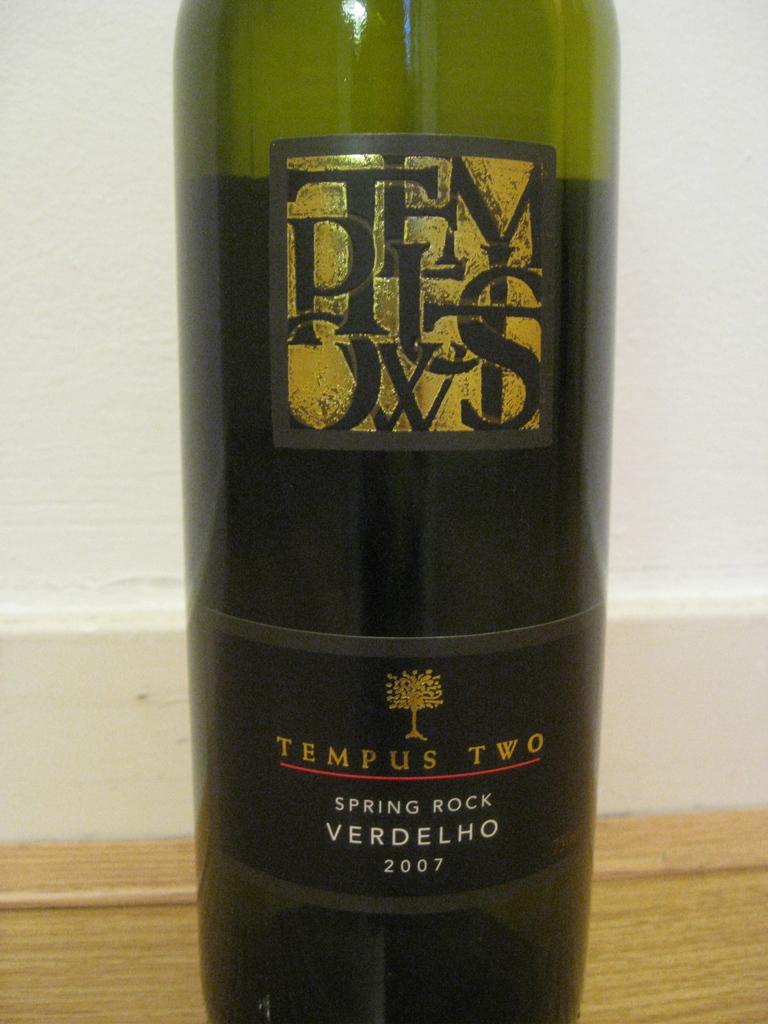Is tempus two a light or dark alcohol flavor?
Your response must be concise. Answering does not require reading text in the image. Where is tempus two made?
Keep it short and to the point. Spring rock. 